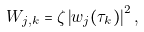Convert formula to latex. <formula><loc_0><loc_0><loc_500><loc_500>W _ { j , k } = \zeta \left | w _ { j } ( \tau _ { k } ) \right | ^ { 2 } ,</formula> 